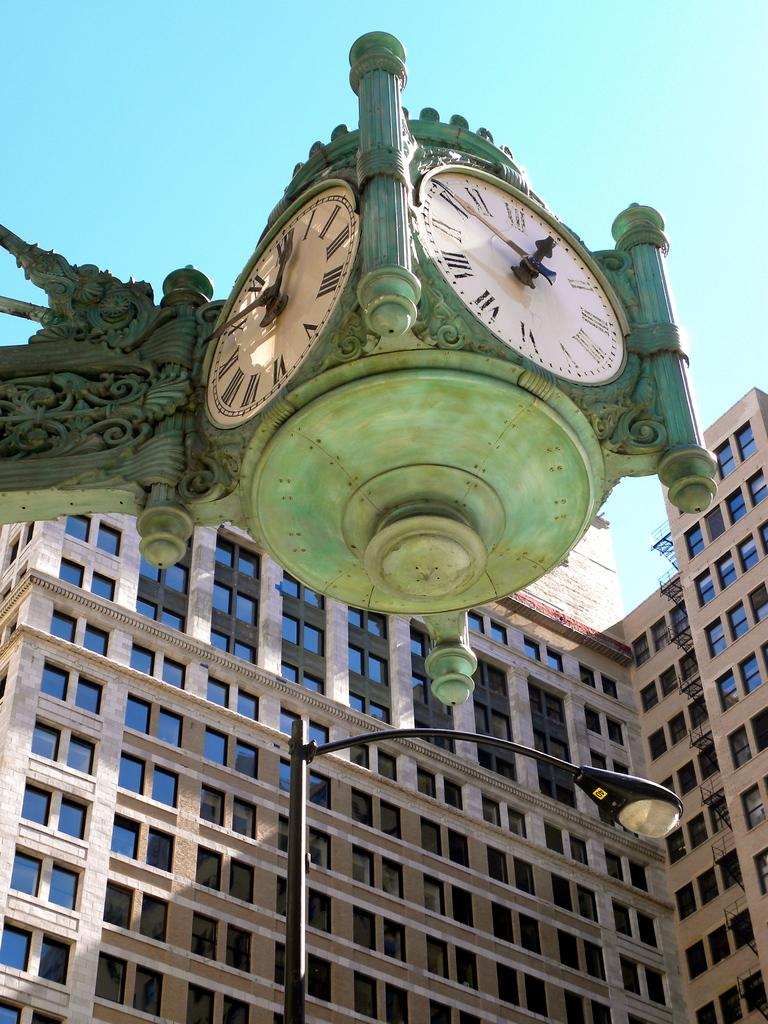What is the main structure visible in the foreground of the image? There is a building in the foreground of the image. What feature can be seen on the building? The building has windows. What other object is present in the foreground of the image? There is a street light in the foreground of the image. What time-telling devices are mounted on a wall in the foreground of the image? There are two clocks mounted on a wall in the foreground of the image. What is the color of the sky in the background of the image? The sky is blue in the background of the image. Based on the sky color, what time of day might the image have been taken? The image was likely taken during the day. What type of screw can be seen holding the floor together in the image? There is no screw visible in the image, nor is there any indication of a floor being held together. 